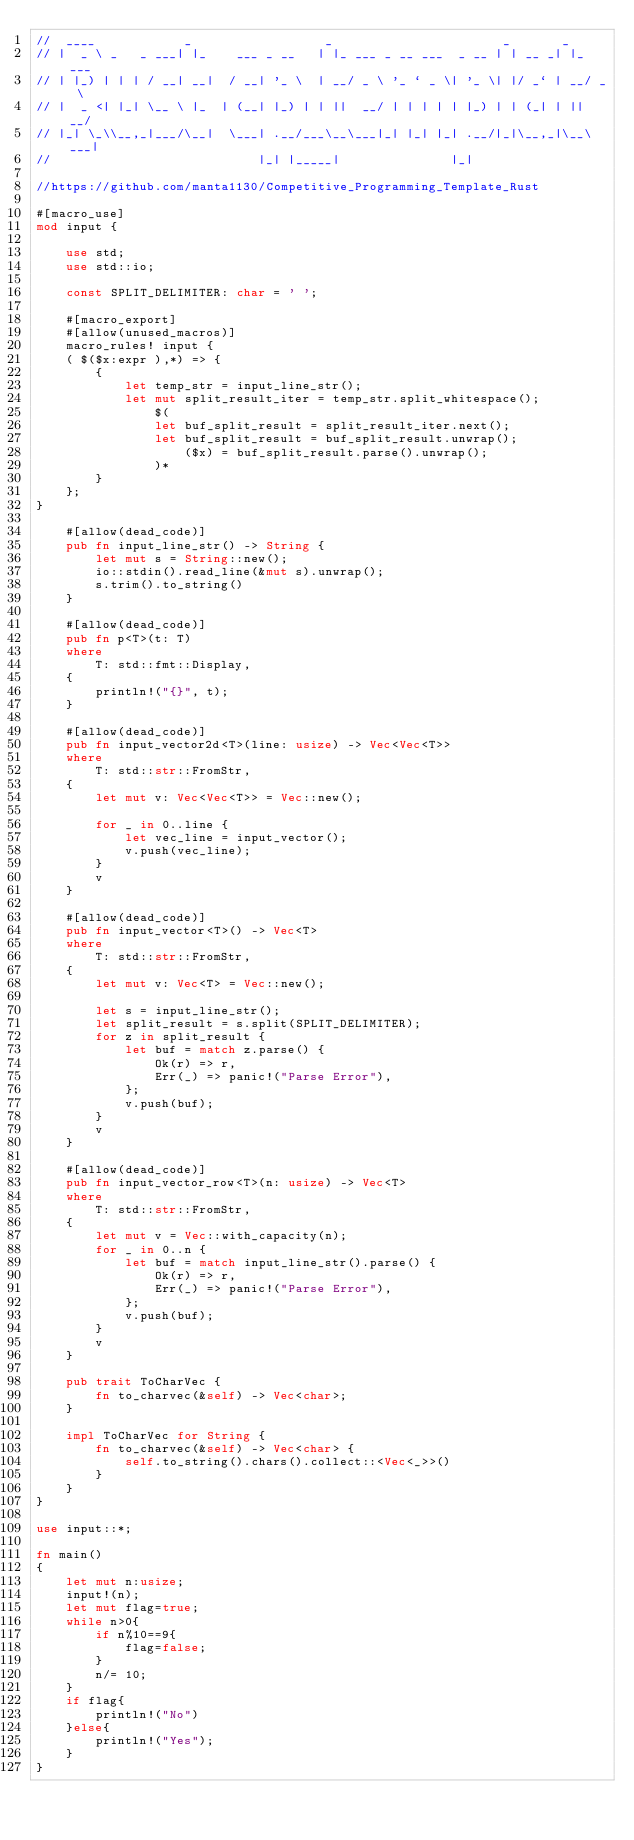Convert code to text. <code><loc_0><loc_0><loc_500><loc_500><_Rust_>//  ____            _                  _                       _       _
// |  _ \ _   _ ___| |_    ___ _ __   | |_ ___ _ __ ___  _ __ | | __ _| |_ ___
// | |_) | | | / __| __|  / __| '_ \  | __/ _ \ '_ ` _ \| '_ \| |/ _` | __/ _ \
// |  _ <| |_| \__ \ |_  | (__| |_) | | ||  __/ | | | | | |_) | | (_| | ||  __/
// |_| \_\\__,_|___/\__|  \___| .__/___\__\___|_| |_| |_| .__/|_|\__,_|\__\___|
//                            |_| |_____|               |_|

//https://github.com/manta1130/Competitive_Programming_Template_Rust

#[macro_use]
mod input {

    use std;
    use std::io;

    const SPLIT_DELIMITER: char = ' ';

    #[macro_export]
    #[allow(unused_macros)]
    macro_rules! input {
    ( $($x:expr ),*) => {
        {
            let temp_str = input_line_str();
            let mut split_result_iter = temp_str.split_whitespace();
                $(
                let buf_split_result = split_result_iter.next();
                let buf_split_result = buf_split_result.unwrap();
                    ($x) = buf_split_result.parse().unwrap();
                )*
        }
    };
}

    #[allow(dead_code)]
    pub fn input_line_str() -> String {
        let mut s = String::new();
        io::stdin().read_line(&mut s).unwrap();
        s.trim().to_string()
    }

    #[allow(dead_code)]
    pub fn p<T>(t: T)
    where
        T: std::fmt::Display,
    {
        println!("{}", t);
    }

    #[allow(dead_code)]
    pub fn input_vector2d<T>(line: usize) -> Vec<Vec<T>>
    where
        T: std::str::FromStr,
    {
        let mut v: Vec<Vec<T>> = Vec::new();

        for _ in 0..line {
            let vec_line = input_vector();
            v.push(vec_line);
        }
        v
    }

    #[allow(dead_code)]
    pub fn input_vector<T>() -> Vec<T>
    where
        T: std::str::FromStr,
    {
        let mut v: Vec<T> = Vec::new();

        let s = input_line_str();
        let split_result = s.split(SPLIT_DELIMITER);
        for z in split_result {
            let buf = match z.parse() {
                Ok(r) => r,
                Err(_) => panic!("Parse Error"),
            };
            v.push(buf);
        }
        v
    }

    #[allow(dead_code)]
    pub fn input_vector_row<T>(n: usize) -> Vec<T>
    where
        T: std::str::FromStr,
    {
        let mut v = Vec::with_capacity(n);
        for _ in 0..n {
            let buf = match input_line_str().parse() {
                Ok(r) => r,
                Err(_) => panic!("Parse Error"),
            };
            v.push(buf);
        }
        v
    }

    pub trait ToCharVec {
        fn to_charvec(&self) -> Vec<char>;
    }

    impl ToCharVec for String {
        fn to_charvec(&self) -> Vec<char> {
            self.to_string().chars().collect::<Vec<_>>()
        }
    }
}

use input::*;

fn main()
{
    let mut n:usize;
    input!(n);
    let mut flag=true;
    while n>0{
        if n%10==9{
            flag=false;
        }
        n/= 10;
    }
    if flag{
        println!("No")
    }else{
        println!("Yes");
    }
}

</code> 